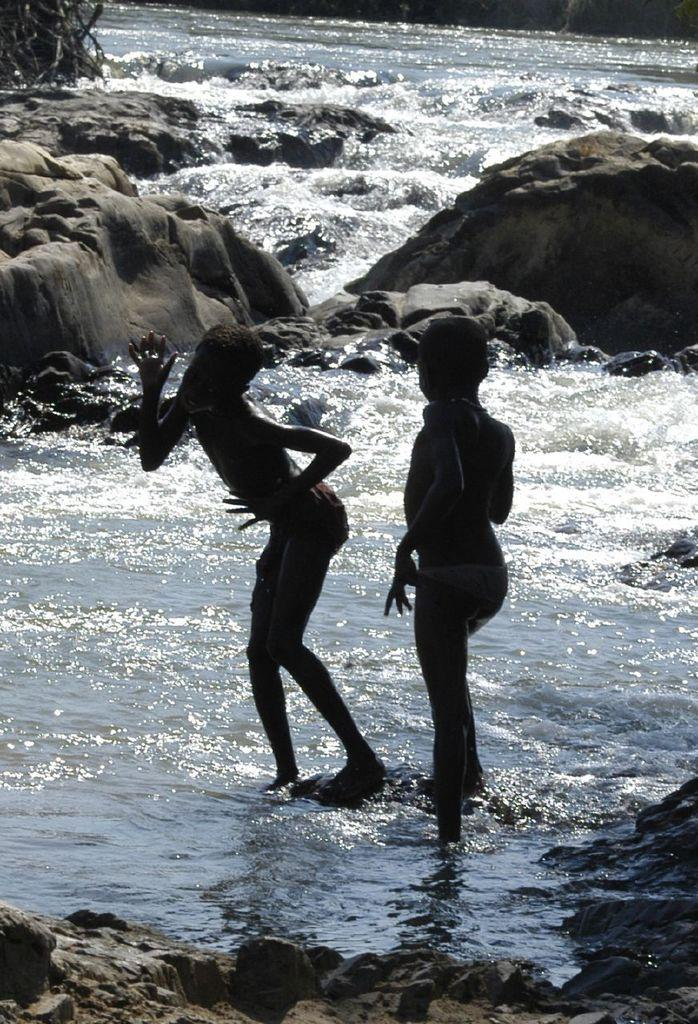How many people are present in the image? There are two people in the image. What is visible in the image besides the people? Water and rocks are visible in the image. What can be seen in the background of the image? There are sticks visible in the background of the image. What is the noise level in the image? There is no information about the noise level in the image, as it is a still image and does not convey sound. 